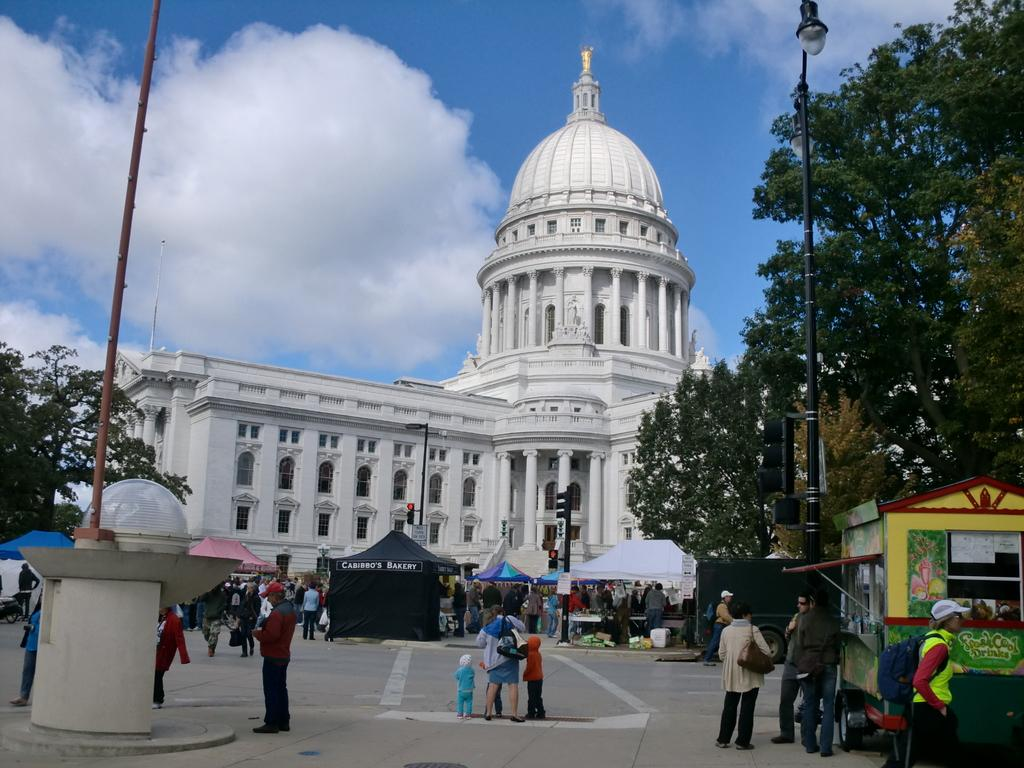What type of structure is present in the image? There is a building in the image. Can you describe the people in the image? There are people standing in the image. What type of vegetation is present in the image? There are trees in the image. What is the color of the sky in the image? The sky is blue in the image. What else can be seen in the sky in the image? There are clouds visible in the image. How many ladybugs are crawling on the glass in the image? There are no ladybugs or glass present in the image. What type of exercise is the tramp performing in the image? There is no tramp or exercise depicted in the image. 